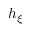Convert formula to latex. <formula><loc_0><loc_0><loc_500><loc_500>h _ { \xi }</formula> 